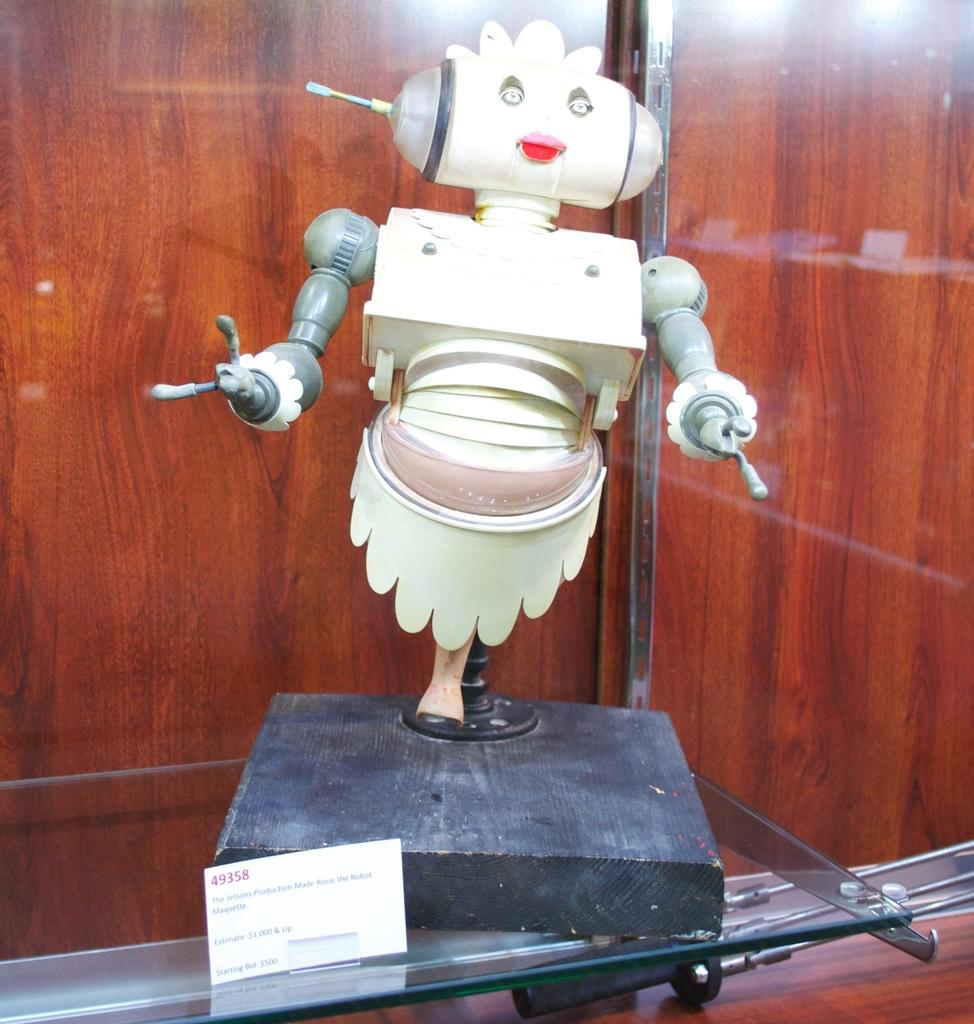What is the main subject of the image? There is a robot in the image. What type of furniture is present in the image? There is a glass cupboard in the image. Is there any additional information provided about the robot or other objects? Yes, there is an information card in the image. What is the material of the wall in the image? There is a wooden wall in the image. How many girls are visible in the image? There are no girls present in the image; it features a robot, a glass cupboard, an information card, and a wooden wall. What type of current is being used to power the robot in the image? The image does not provide information about the type of current being used to power the robot, nor is there any indication that the robot is powered by electricity. 